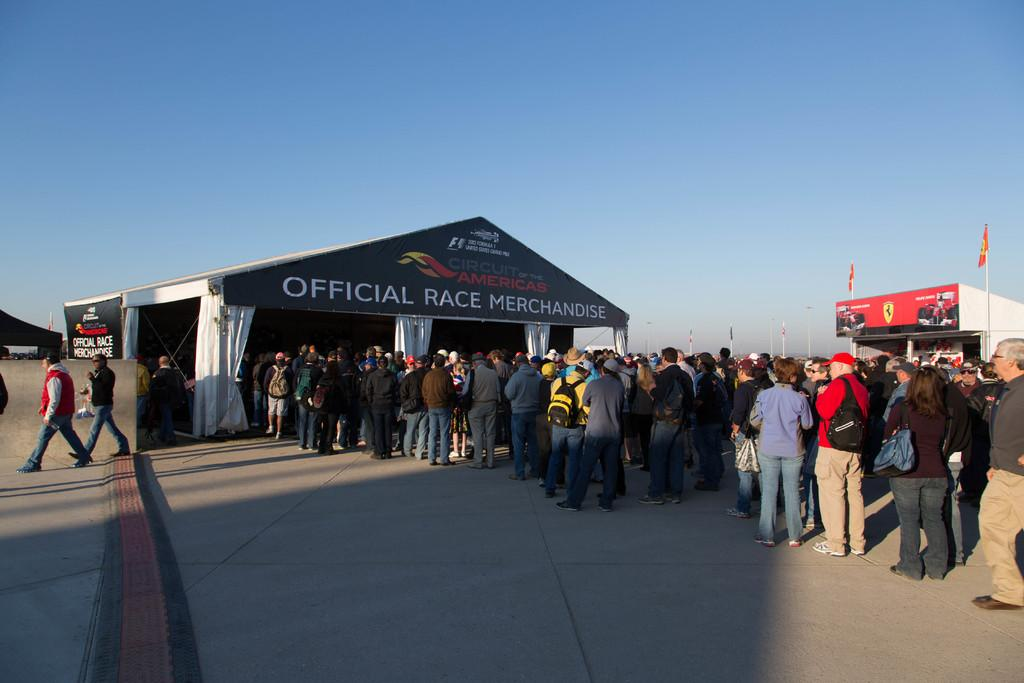What type of structures are visible in the image? There are tents in the image. What are the people doing near the tents? People are standing in lines to enter the tents. Are there any other activities happening in the image? Yes, there are people walking in the image. What color is the notebook being carried by the person walking in the image? There is no notebook present in the image; it only shows tents, people standing in lines, and people walking. 